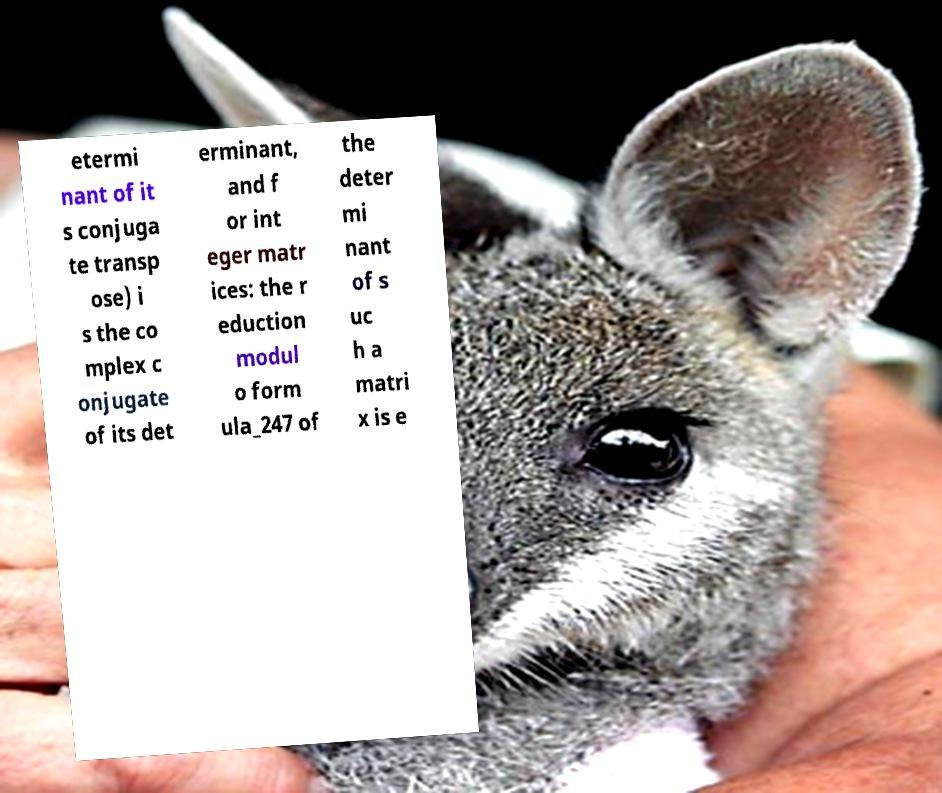What messages or text are displayed in this image? I need them in a readable, typed format. etermi nant of it s conjuga te transp ose) i s the co mplex c onjugate of its det erminant, and f or int eger matr ices: the r eduction modul o form ula_247 of the deter mi nant of s uc h a matri x is e 